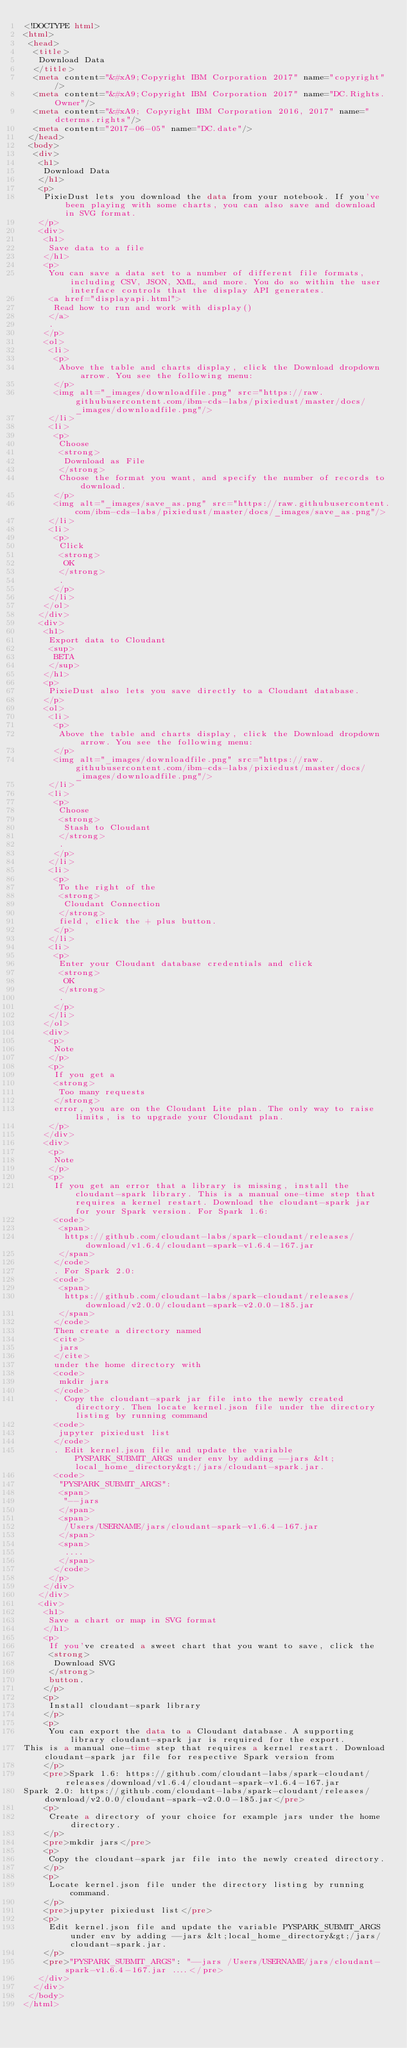Convert code to text. <code><loc_0><loc_0><loc_500><loc_500><_HTML_><!DOCTYPE html>
<html>
 <head>
  <title>
   Download Data
  </title>
  <meta content="&#xA9;Copyright IBM Corporation 2017" name="copyright"/>
  <meta content="&#xA9;Copyright IBM Corporation 2017" name="DC.Rights.Owner"/>
  <meta content="&#xA9; Copyright IBM Corporation 2016, 2017" name="dcterms.rights"/>
  <meta content="2017-06-05" name="DC.date"/>
 </head>
 <body>
  <div>
   <h1>
    Download Data
   </h1>
   <p>
    PixieDust lets you download the data from your notebook. If you've been playing with some charts, you can also save and download in SVG format.
   </p>
   <div>
    <h1>
     Save data to a file
    </h1>
    <p>
     You can save a data set to a number of different file formats, including CSV, JSON, XML, and more. You do so within the user interface controls that the display API generates.
     <a href="displayapi.html">
      Read how to run and work with display()
     </a>
     .
    </p>
    <ol>
     <li>
      <p>
       Above the table and charts display, click the Download dropdown arrow. You see the following menu:
      </p>
      <img alt="_images/downloadfile.png" src="https://raw.githubusercontent.com/ibm-cds-labs/pixiedust/master/docs/_images/downloadfile.png"/>
     </li>
     <li>
      <p>
       Choose
       <strong>
        Download as File
       </strong>
       Choose the format you want, and specify the number of records to download.
      </p>
      <img alt="_images/save_as.png" src="https://raw.githubusercontent.com/ibm-cds-labs/pixiedust/master/docs/_images/save_as.png"/>
     </li>
     <li>
      <p>
       Click
       <strong>
        OK
       </strong>
       .
      </p>
     </li>
    </ol>
   </div>
   <div>
    <h1>
     Export data to Cloudant
     <sup>
      BETA
     </sup>
    </h1>
    <p>
     PixieDust also lets you save directly to a Cloudant database.
    </p>
    <ol>
     <li>
      <p>
       Above the table and charts display, click the Download dropdown arrow. You see the following menu:
      </p>
      <img alt="_images/downloadfile.png" src="https://raw.githubusercontent.com/ibm-cds-labs/pixiedust/master/docs/_images/downloadfile.png"/>
     </li>
     <li>
      <p>
       Choose
       <strong>
        Stash to Cloudant
       </strong>
       .
      </p>
     </li>
     <li>
      <p>
       To the right of the
       <strong>
        Cloudant Connection
       </strong>
       field, click the + plus button.
      </p>
     </li>
     <li>
      <p>
       Enter your Cloudant database credentials and click
       <strong>
        OK
       </strong>
       .
      </p>
     </li>
    </ol>
    <div>
     <p>
      Note
     </p>
     <p>
      If you get a
      <strong>
       Too many requests
      </strong>
      error, you are on the Cloudant Lite plan. The only way to raise limits, is to upgrade your Cloudant plan.
     </p>
    </div>
    <div>
     <p>
      Note
     </p>
     <p>
      If you get an error that a library is missing, install the cloudant-spark library. This is a manual one-time step that requires a kernel restart. Download the cloudant-spark jar for your Spark version. For Spark 1.6:
      <code>
       <span>
        https://github.com/cloudant-labs/spark-cloudant/releases/download/v1.6.4/cloudant-spark-v1.6.4-167.jar
       </span>
      </code>
      . For Spark 2.0:
      <code>
       <span>
        https://github.com/cloudant-labs/spark-cloudant/releases/download/v2.0.0/cloudant-spark-v2.0.0-185.jar
       </span>
      </code>
      Then create a directory named
      <cite>
       jars
      </cite>
      under the home directory with
      <code>
       mkdir jars
      </code>
      . Copy the cloudant-spark jar file into the newly created directory. Then locate kernel.json file under the directory listing by running command
      <code>
       jupyter pixiedust list
      </code>
      . Edit kernel.json file and update the variable PYSPARK_SUBMIT_ARGS under env by adding --jars &lt;local_home_directory&gt;/jars/cloudant-spark.jar.
      <code>
       "PYSPARK_SUBMIT_ARGS":
       <span>
        "--jars
       </span>
       <span>
        /Users/USERNAME/jars/cloudant-spark-v1.6.4-167.jar
       </span>
       <span>
        ....
       </span>
      </code>
     </p>
    </div>
   </div>
   <div>
    <h1>
     Save a chart or map in SVG format
    </h1>
    <p>
     If you've created a sweet chart that you want to save, click the
     <strong>
      Download SVG
     </strong>
     button.
    </p>
    <p>
     Install cloudant-spark library
    </p>
    <p>
     You can export the data to a Cloudant database. A supporting library cloudant-spark jar is required for the export.
This is a manual one-time step that requires a kernel restart. Download cloudant-spark jar file for respective Spark version from
    </p>
    <pre>Spark 1.6: https://github.com/cloudant-labs/spark-cloudant/releases/download/v1.6.4/cloudant-spark-v1.6.4-167.jar
Spark 2.0: https://github.com/cloudant-labs/spark-cloudant/releases/download/v2.0.0/cloudant-spark-v2.0.0-185.jar</pre>
    <p>
     Create a directory of your choice for example jars under the home directory.
    </p>
    <pre>mkdir jars</pre>
    <p>
     Copy the cloudant-spark jar file into the newly created directory.
    </p>
    <p>
     Locate kernel.json file under the directory listing by running command.
    </p>
    <pre>jupyter pixiedust list</pre>
    <p>
     Edit kernel.json file and update the variable PYSPARK_SUBMIT_ARGS under env by adding --jars &lt;local_home_directory&gt;/jars/cloudant-spark.jar.
    </p>
    <pre>"PYSPARK_SUBMIT_ARGS": "--jars /Users/USERNAME/jars/cloudant-spark-v1.6.4-167.jar ....</pre>
   </div>
  </div>
 </body>
</html>
</code> 